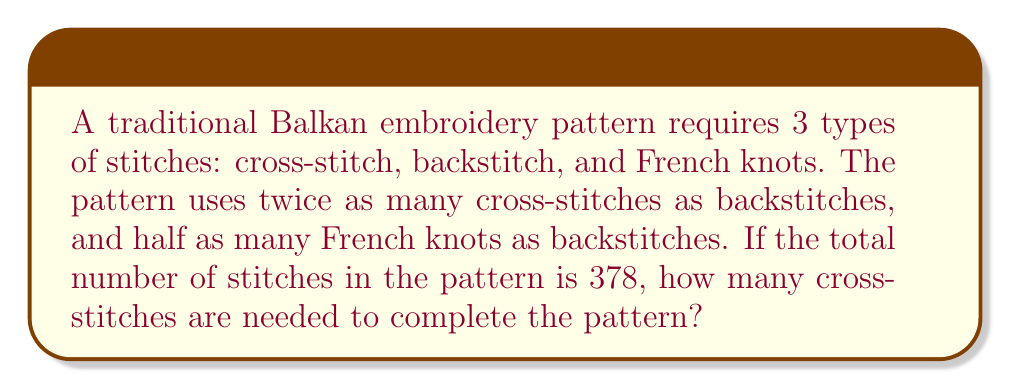Solve this math problem. Let's solve this step-by-step:

1) Let $x$ be the number of backstitches.
2) Then, the number of cross-stitches is $2x$.
3) The number of French knots is $\frac{1}{2}x$.

4) We know that the total number of stitches is 378, so we can set up an equation:
   $$ x + 2x + \frac{1}{2}x = 378 $$

5) Simplify the left side of the equation:
   $$ \frac{7}{2}x = 378 $$

6) Multiply both sides by $\frac{2}{7}$ to isolate $x$:
   $$ x = 378 \cdot \frac{2}{7} = 108 $$

7) Remember, $x$ represents the number of backstitches. We want to know the number of cross-stitches, which is $2x$.

8) Therefore, the number of cross-stitches is:
   $$ 2x = 2 \cdot 108 = 216 $$
Answer: 216 